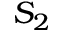<formula> <loc_0><loc_0><loc_500><loc_500>S _ { 2 }</formula> 